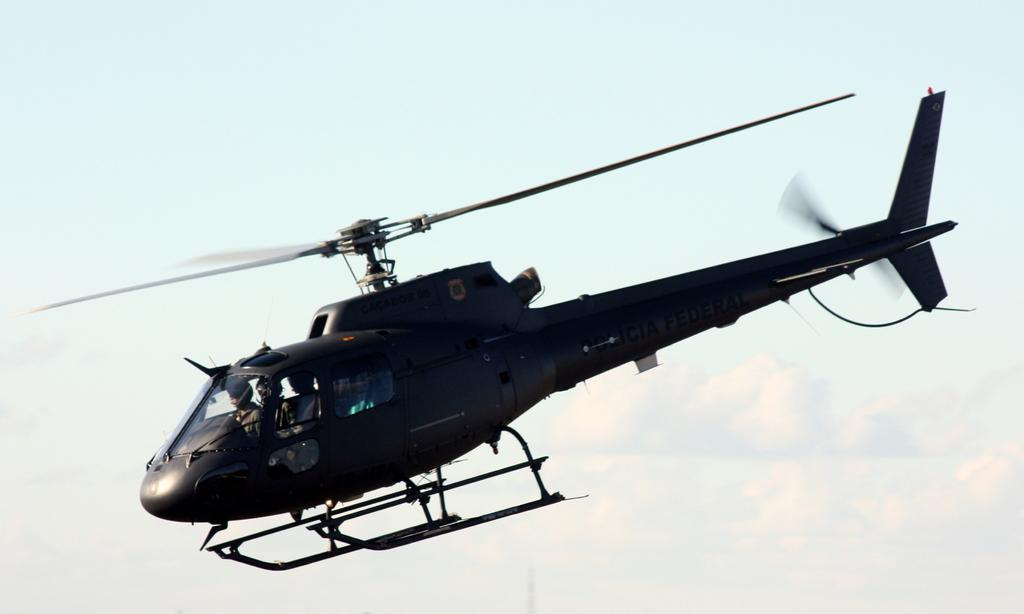What is the main subject of the picture? The main subject of the picture is a helicopter. What else can be seen in the picture besides the helicopter? There are people seated in the picture. How would you describe the sky in the picture? The sky is blue and cloudy. Can you tell me how many leaves are on the helicopter in the image? There are no leaves present in the image, as it features a helicopter and people seated. 